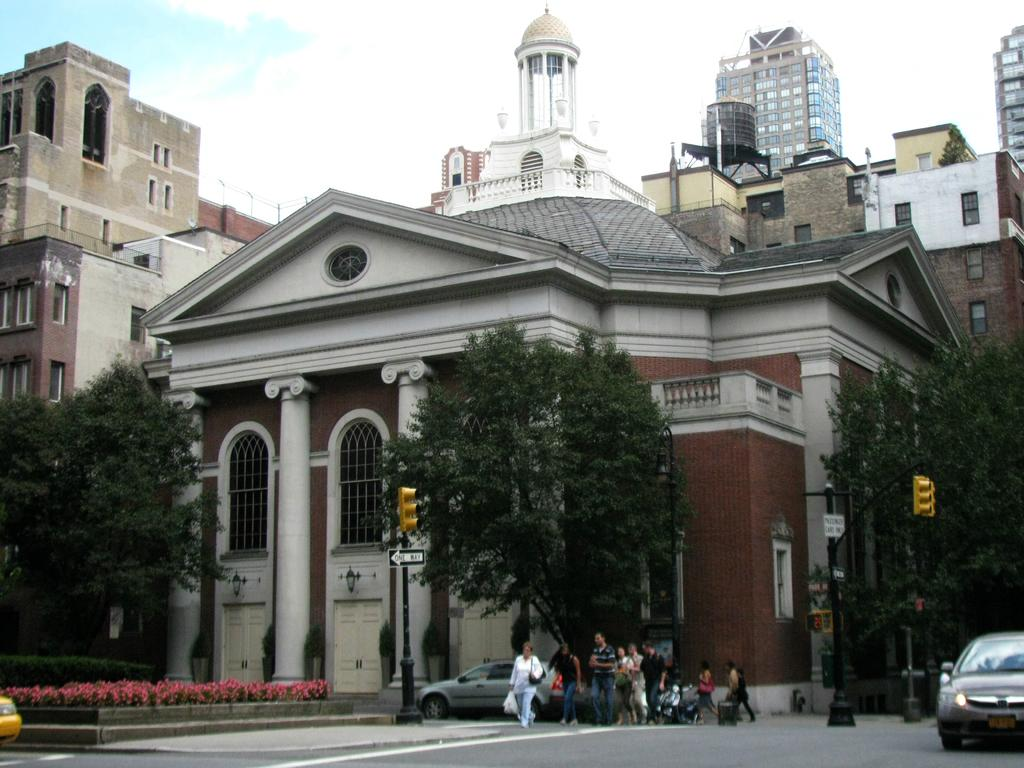What type of vehicles can be seen on the road in the image? There are cars on the road in the image. Are there any people present in the image? Yes, there are people on the road in the image. What structures can be seen in the image? Poles, traffic signals, boards, trees, plants, flowers, buildings, doors, and windows are visible in the image. What is visible in the background of the image? The sky is visible in the background of the image. What type of tent can be seen in the image? There is no tent present in the image. What is the size of the brick used to build the buildings in the image? There is no specific information about the size of bricks used to build the buildings in the image. 